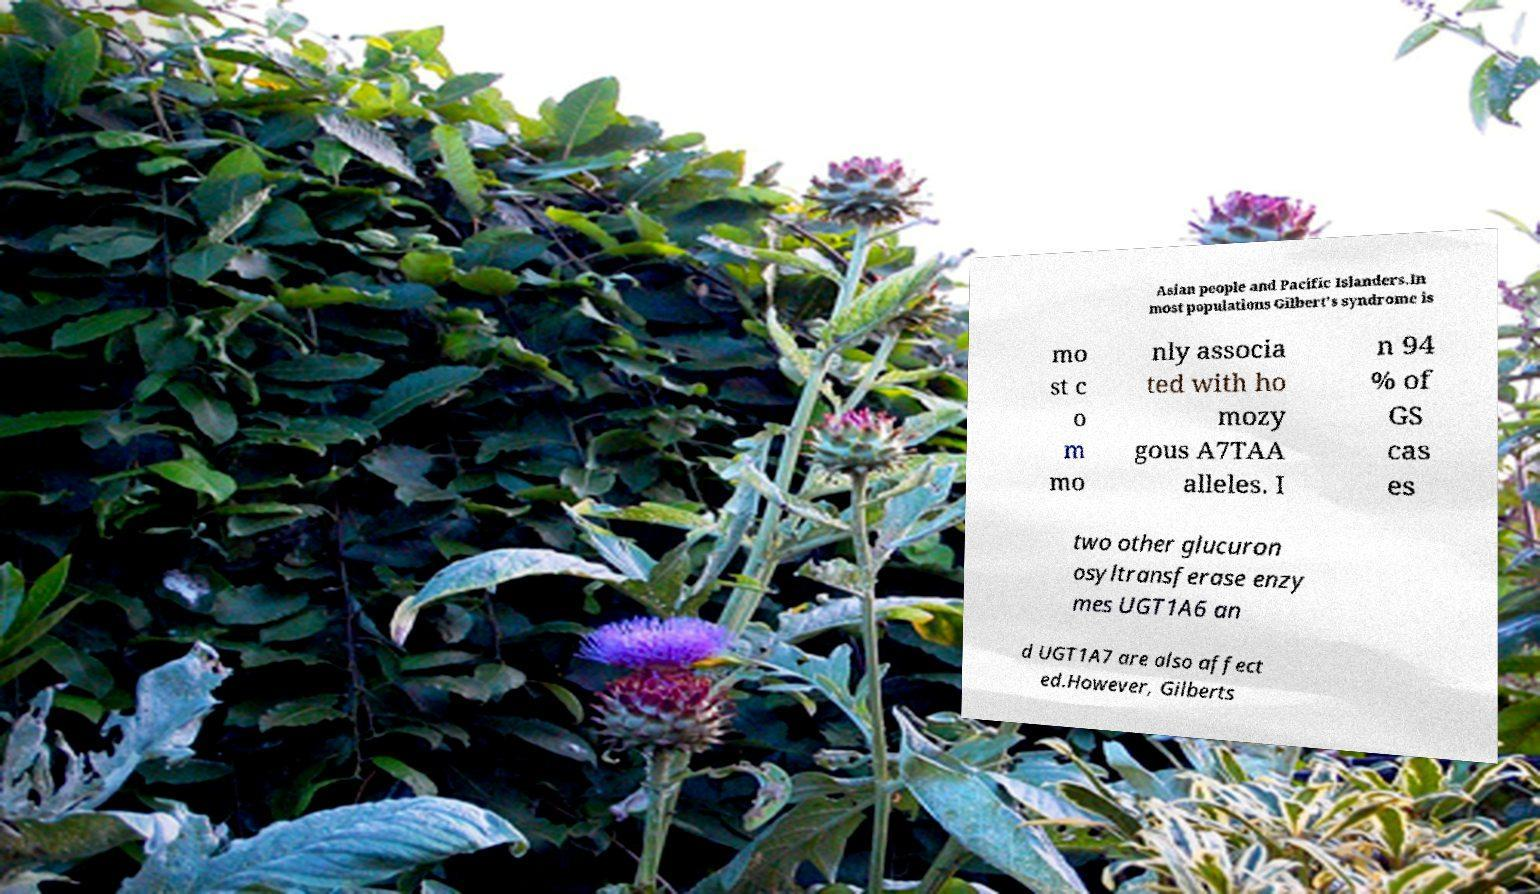Can you read and provide the text displayed in the image?This photo seems to have some interesting text. Can you extract and type it out for me? Asian people and Pacific Islanders.In most populations Gilbert's syndrome is mo st c o m mo nly associa ted with ho mozy gous A7TAA alleles. I n 94 % of GS cas es two other glucuron osyltransferase enzy mes UGT1A6 an d UGT1A7 are also affect ed.However, Gilberts 